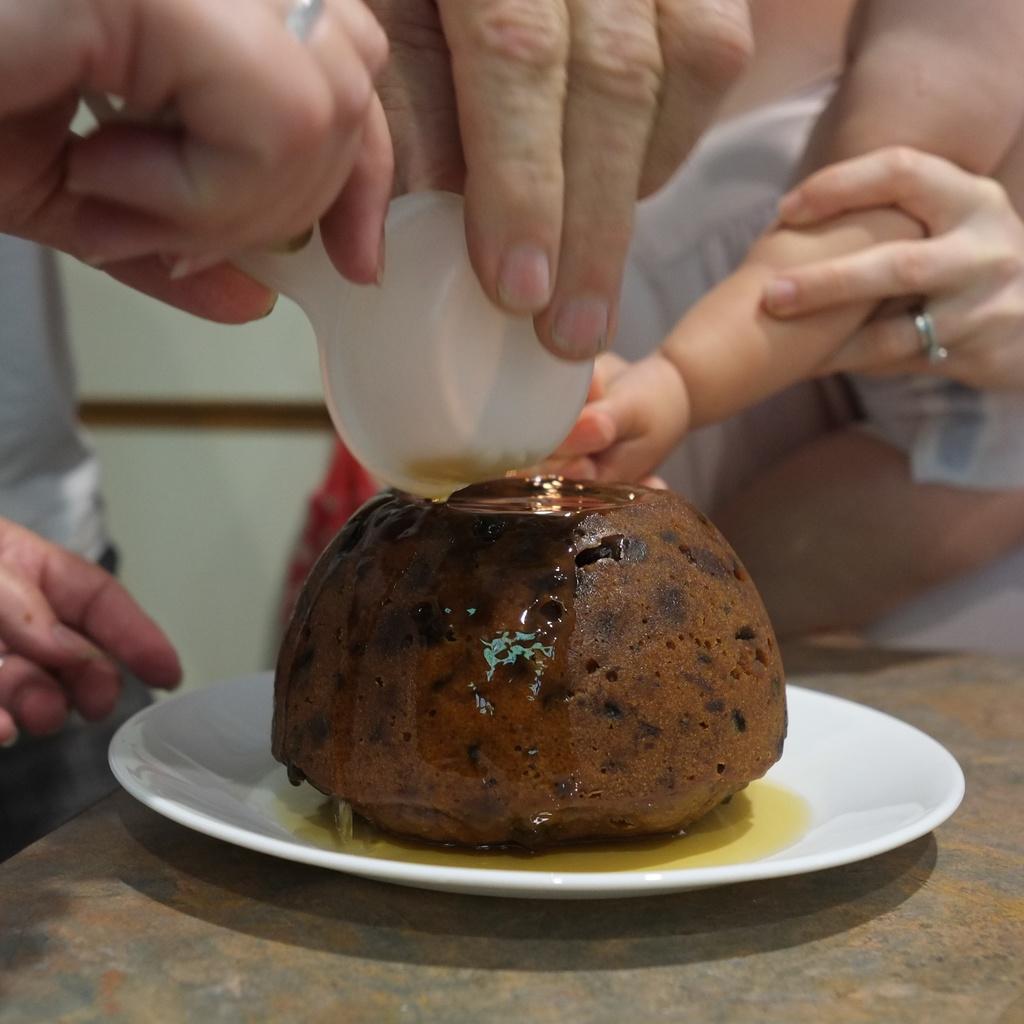Could you give a brief overview of what you see in this image? In this image there is some food on the plate which is on the table. Few persons are holding the spoon and keeping it on the food. A person is holding the hand of a kid. 